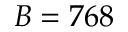<formula> <loc_0><loc_0><loc_500><loc_500>B = 7 6 8</formula> 